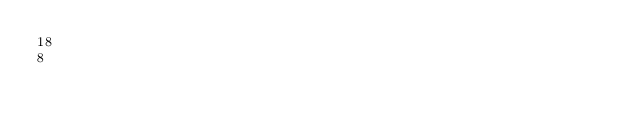Convert code to text. <code><loc_0><loc_0><loc_500><loc_500><_SQL_>18
8</code> 